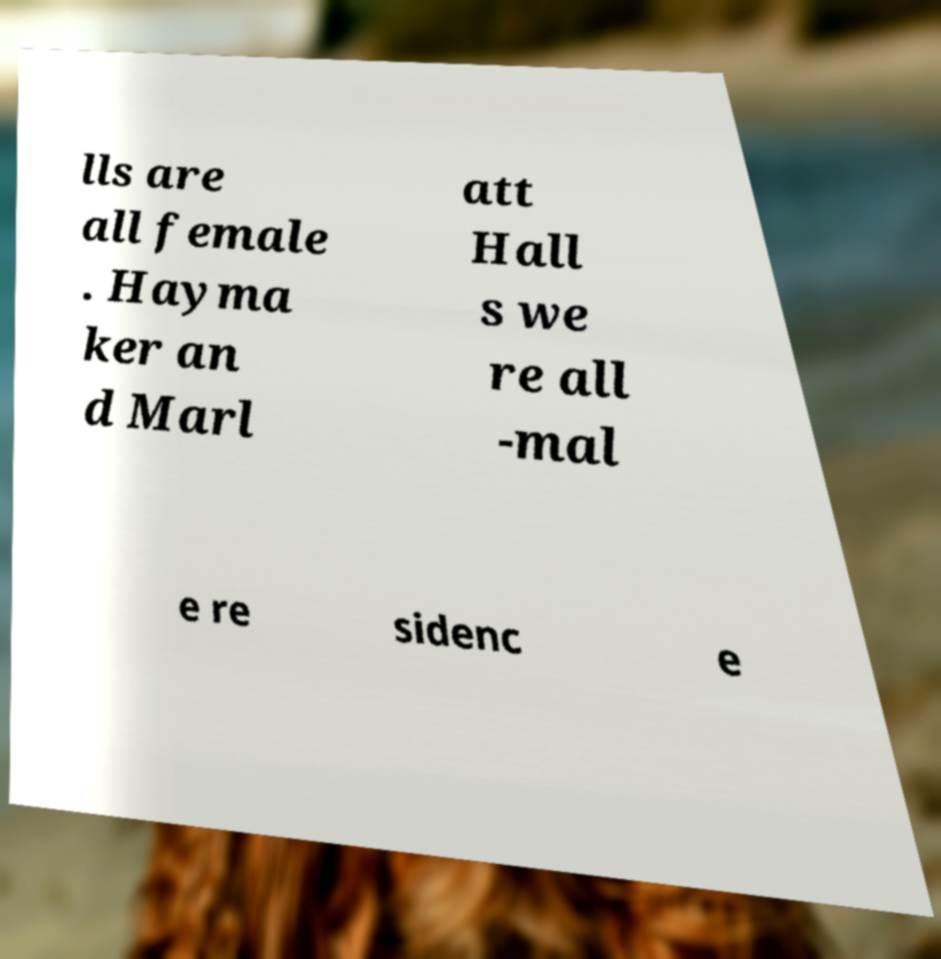What messages or text are displayed in this image? I need them in a readable, typed format. lls are all female . Hayma ker an d Marl att Hall s we re all -mal e re sidenc e 